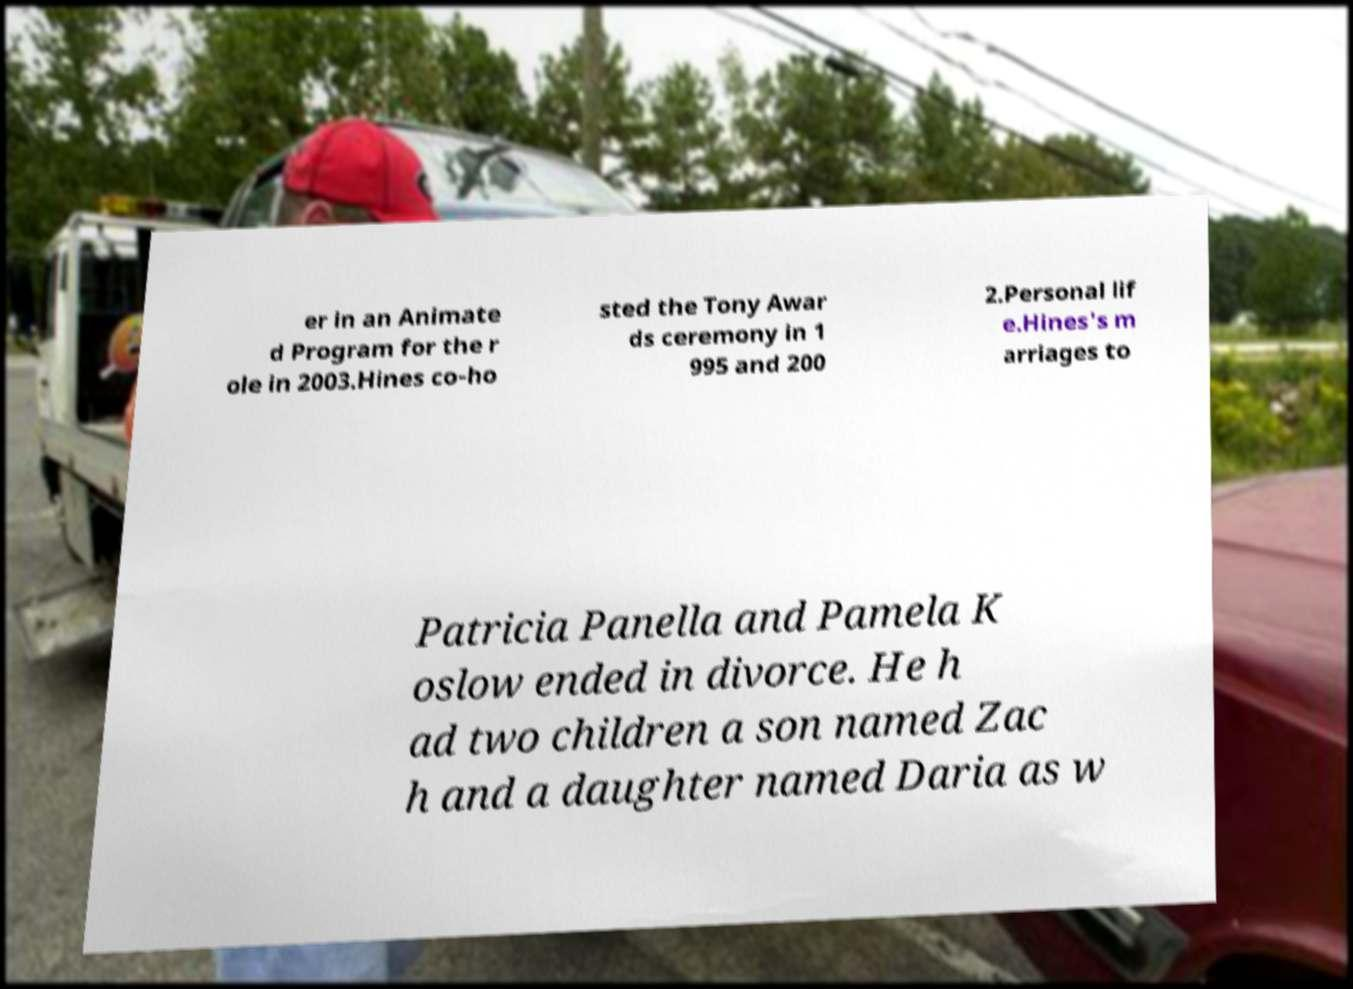Could you assist in decoding the text presented in this image and type it out clearly? er in an Animate d Program for the r ole in 2003.Hines co-ho sted the Tony Awar ds ceremony in 1 995 and 200 2.Personal lif e.Hines's m arriages to Patricia Panella and Pamela K oslow ended in divorce. He h ad two children a son named Zac h and a daughter named Daria as w 